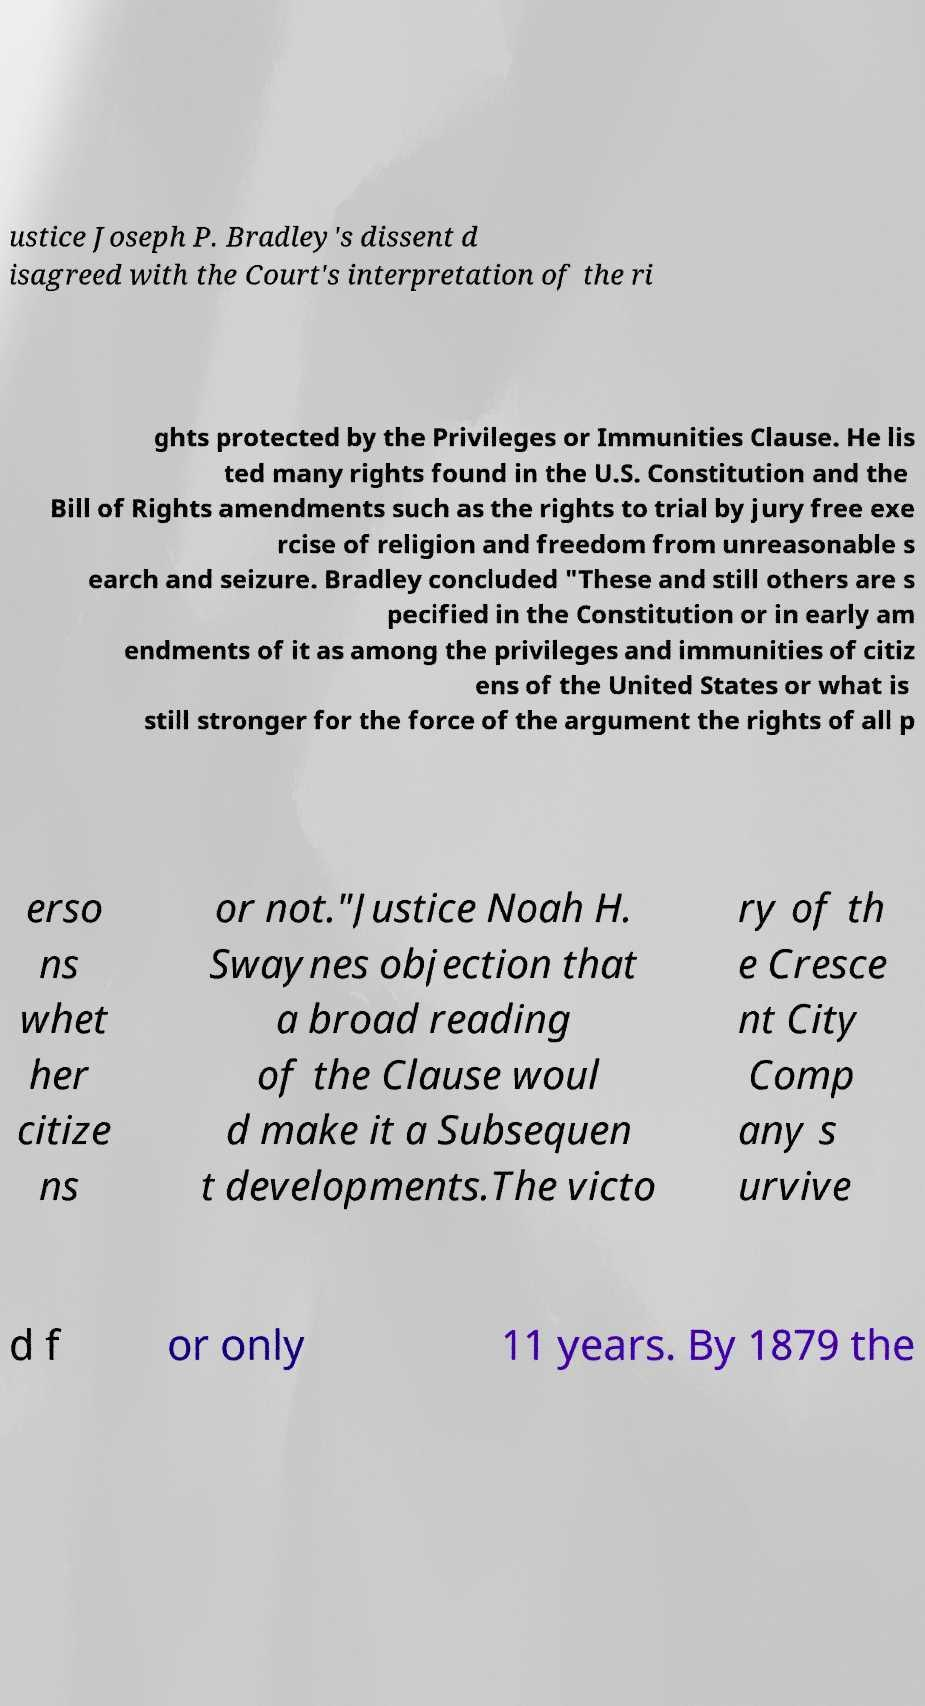Could you assist in decoding the text presented in this image and type it out clearly? ustice Joseph P. Bradley's dissent d isagreed with the Court's interpretation of the ri ghts protected by the Privileges or Immunities Clause. He lis ted many rights found in the U.S. Constitution and the Bill of Rights amendments such as the rights to trial by jury free exe rcise of religion and freedom from unreasonable s earch and seizure. Bradley concluded "These and still others are s pecified in the Constitution or in early am endments of it as among the privileges and immunities of citiz ens of the United States or what is still stronger for the force of the argument the rights of all p erso ns whet her citize ns or not."Justice Noah H. Swaynes objection that a broad reading of the Clause woul d make it a Subsequen t developments.The victo ry of th e Cresce nt City Comp any s urvive d f or only 11 years. By 1879 the 